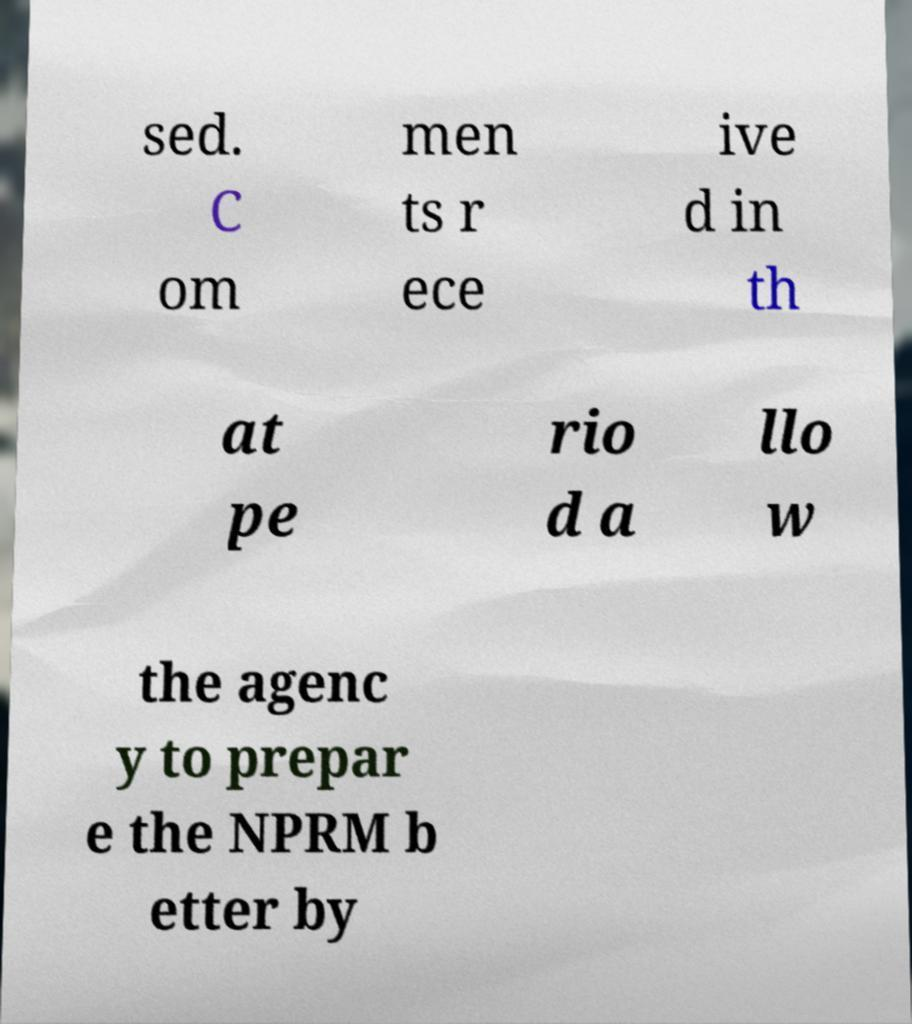For documentation purposes, I need the text within this image transcribed. Could you provide that? sed. C om men ts r ece ive d in th at pe rio d a llo w the agenc y to prepar e the NPRM b etter by 